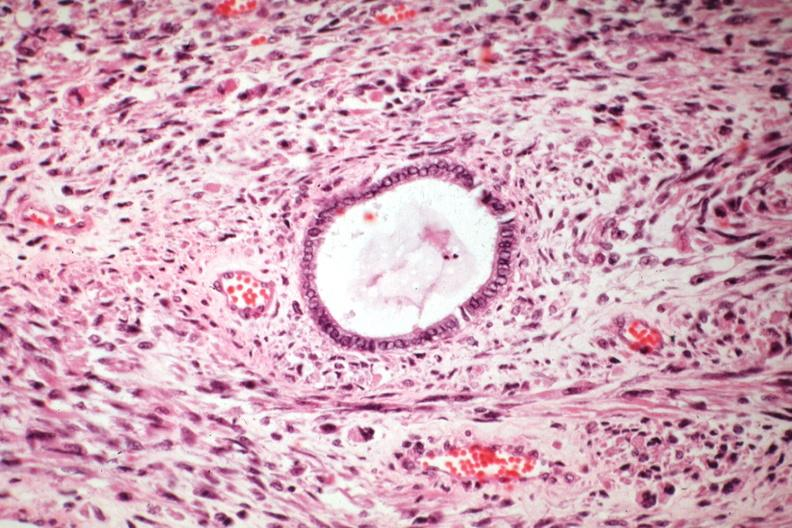s this typical lesion present?
Answer the question using a single word or phrase. No 